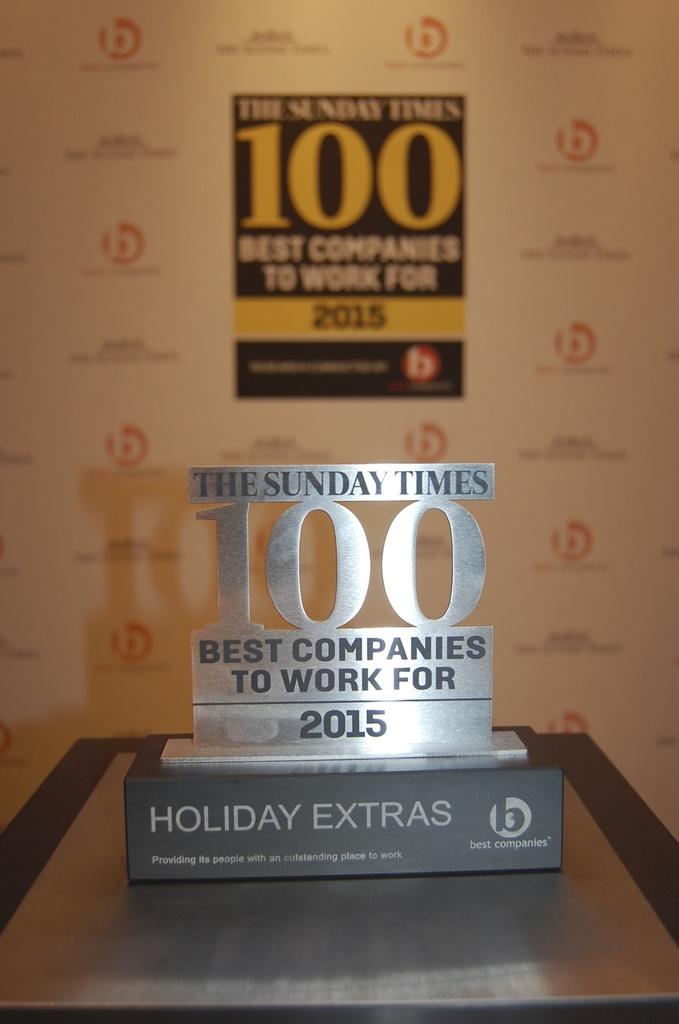What year was this award for?
Provide a short and direct response. 2015. What was this award for?
Your answer should be very brief. Best companies to work for. 